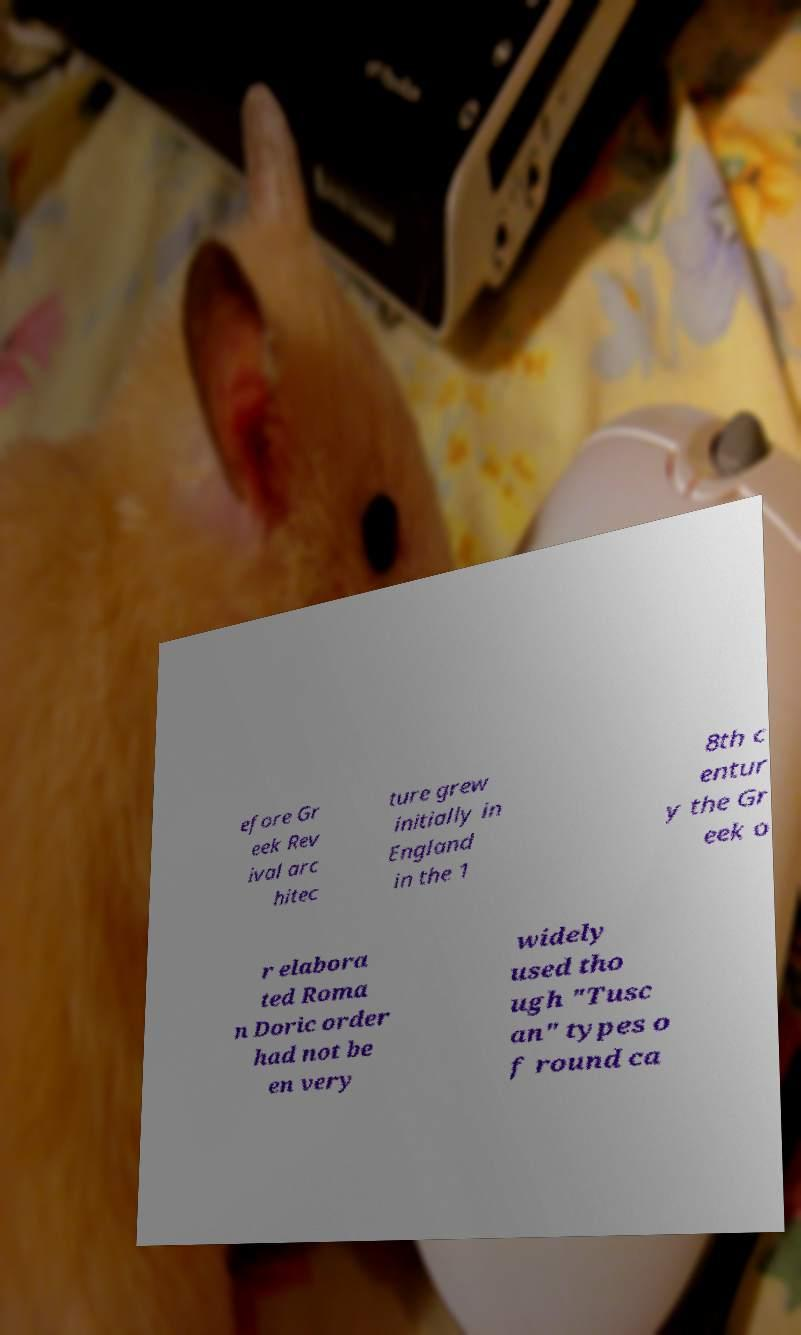There's text embedded in this image that I need extracted. Can you transcribe it verbatim? efore Gr eek Rev ival arc hitec ture grew initially in England in the 1 8th c entur y the Gr eek o r elabora ted Roma n Doric order had not be en very widely used tho ugh "Tusc an" types o f round ca 